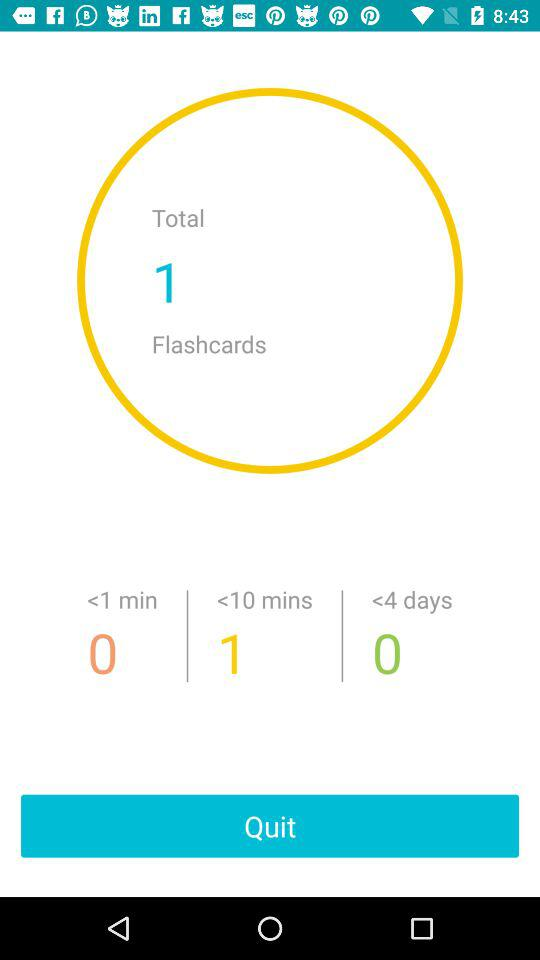How many flashcards are there in total?
Answer the question using a single word or phrase. 1 